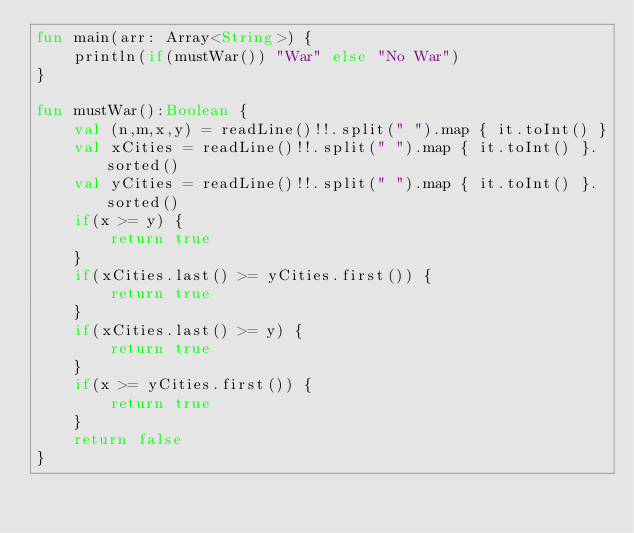<code> <loc_0><loc_0><loc_500><loc_500><_Kotlin_>fun main(arr: Array<String>) {
    println(if(mustWar()) "War" else "No War")
}

fun mustWar():Boolean {
    val (n,m,x,y) = readLine()!!.split(" ").map { it.toInt() }
    val xCities = readLine()!!.split(" ").map { it.toInt() }.sorted()
    val yCities = readLine()!!.split(" ").map { it.toInt() }.sorted()
    if(x >= y) {
        return true
    }
    if(xCities.last() >= yCities.first()) {
        return true
    }
    if(xCities.last() >= y) {
        return true
    }
    if(x >= yCities.first()) {
        return true
    }
    return false
}
</code> 